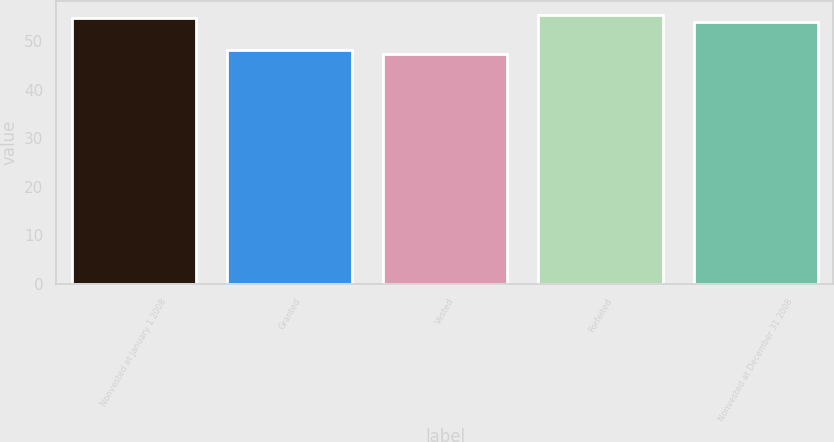<chart> <loc_0><loc_0><loc_500><loc_500><bar_chart><fcel>Nonvested at January 1 2008<fcel>Granted<fcel>Vested<fcel>Forfeited<fcel>Nonvested at December 31 2008<nl><fcel>54.66<fcel>48.04<fcel>47.35<fcel>55.35<fcel>53.97<nl></chart> 